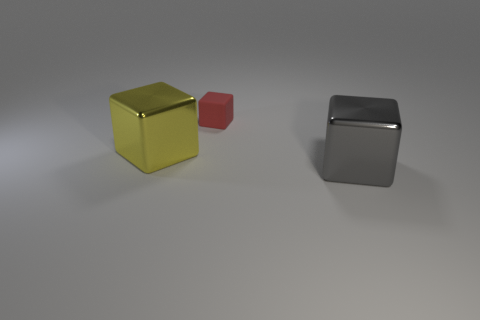Is there any other thing that is the same size as the matte object?
Give a very brief answer. No. Is there a red rubber cube that has the same size as the gray shiny block?
Provide a short and direct response. No. There is a shiny thing that is to the right of the large yellow block that is on the left side of the matte thing; are there any matte blocks right of it?
Offer a very short reply. No. What is the big cube that is on the left side of the object in front of the big metallic object behind the large gray cube made of?
Offer a terse response. Metal. The metal object that is in front of the big yellow object has what shape?
Keep it short and to the point. Cube. The block that is made of the same material as the yellow object is what size?
Keep it short and to the point. Large. How many other tiny rubber things are the same shape as the red thing?
Ensure brevity in your answer.  0. There is a metallic block that is to the right of the tiny matte object; is it the same color as the rubber thing?
Provide a succinct answer. No. What number of rubber blocks are to the right of the large shiny block that is to the right of the large metallic cube that is to the left of the rubber object?
Your response must be concise. 0. How many objects are to the right of the yellow thing and behind the big gray block?
Offer a very short reply. 1. 